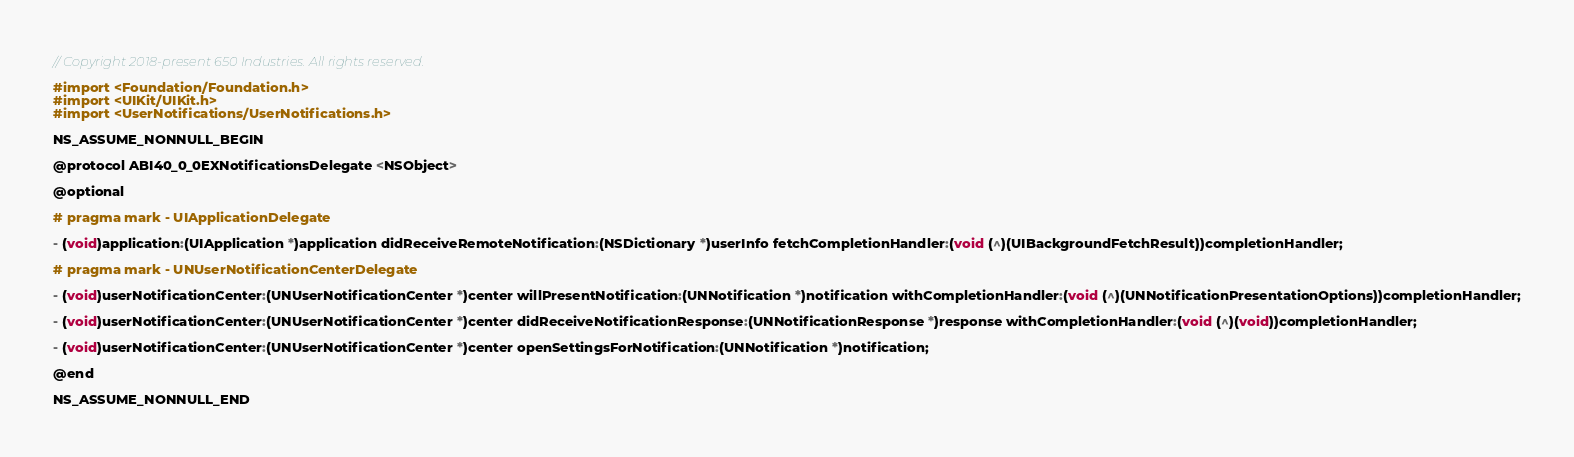Convert code to text. <code><loc_0><loc_0><loc_500><loc_500><_C_>// Copyright 2018-present 650 Industries. All rights reserved.

#import <Foundation/Foundation.h>
#import <UIKit/UIKit.h>
#import <UserNotifications/UserNotifications.h>

NS_ASSUME_NONNULL_BEGIN

@protocol ABI40_0_0EXNotificationsDelegate <NSObject>

@optional

# pragma mark - UIApplicationDelegate

- (void)application:(UIApplication *)application didReceiveRemoteNotification:(NSDictionary *)userInfo fetchCompletionHandler:(void (^)(UIBackgroundFetchResult))completionHandler;

# pragma mark - UNUserNotificationCenterDelegate

- (void)userNotificationCenter:(UNUserNotificationCenter *)center willPresentNotification:(UNNotification *)notification withCompletionHandler:(void (^)(UNNotificationPresentationOptions))completionHandler;

- (void)userNotificationCenter:(UNUserNotificationCenter *)center didReceiveNotificationResponse:(UNNotificationResponse *)response withCompletionHandler:(void (^)(void))completionHandler;

- (void)userNotificationCenter:(UNUserNotificationCenter *)center openSettingsForNotification:(UNNotification *)notification;

@end

NS_ASSUME_NONNULL_END
</code> 